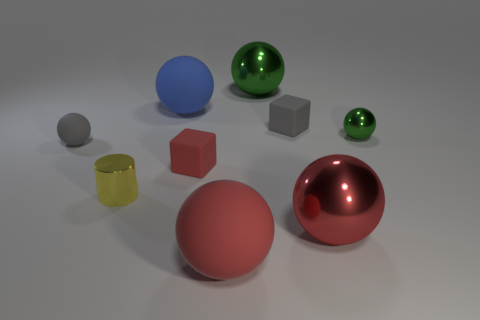Subtract all blue cubes. How many green balls are left? 2 Subtract all tiny gray spheres. How many spheres are left? 5 Subtract all blue spheres. How many spheres are left? 5 Add 1 large cyan balls. How many objects exist? 10 Subtract 4 spheres. How many spheres are left? 2 Subtract all brown spheres. Subtract all gray cylinders. How many spheres are left? 6 Subtract all cubes. How many objects are left? 7 Subtract all cubes. Subtract all tiny gray cubes. How many objects are left? 6 Add 8 tiny rubber cubes. How many tiny rubber cubes are left? 10 Add 5 tiny things. How many tiny things exist? 10 